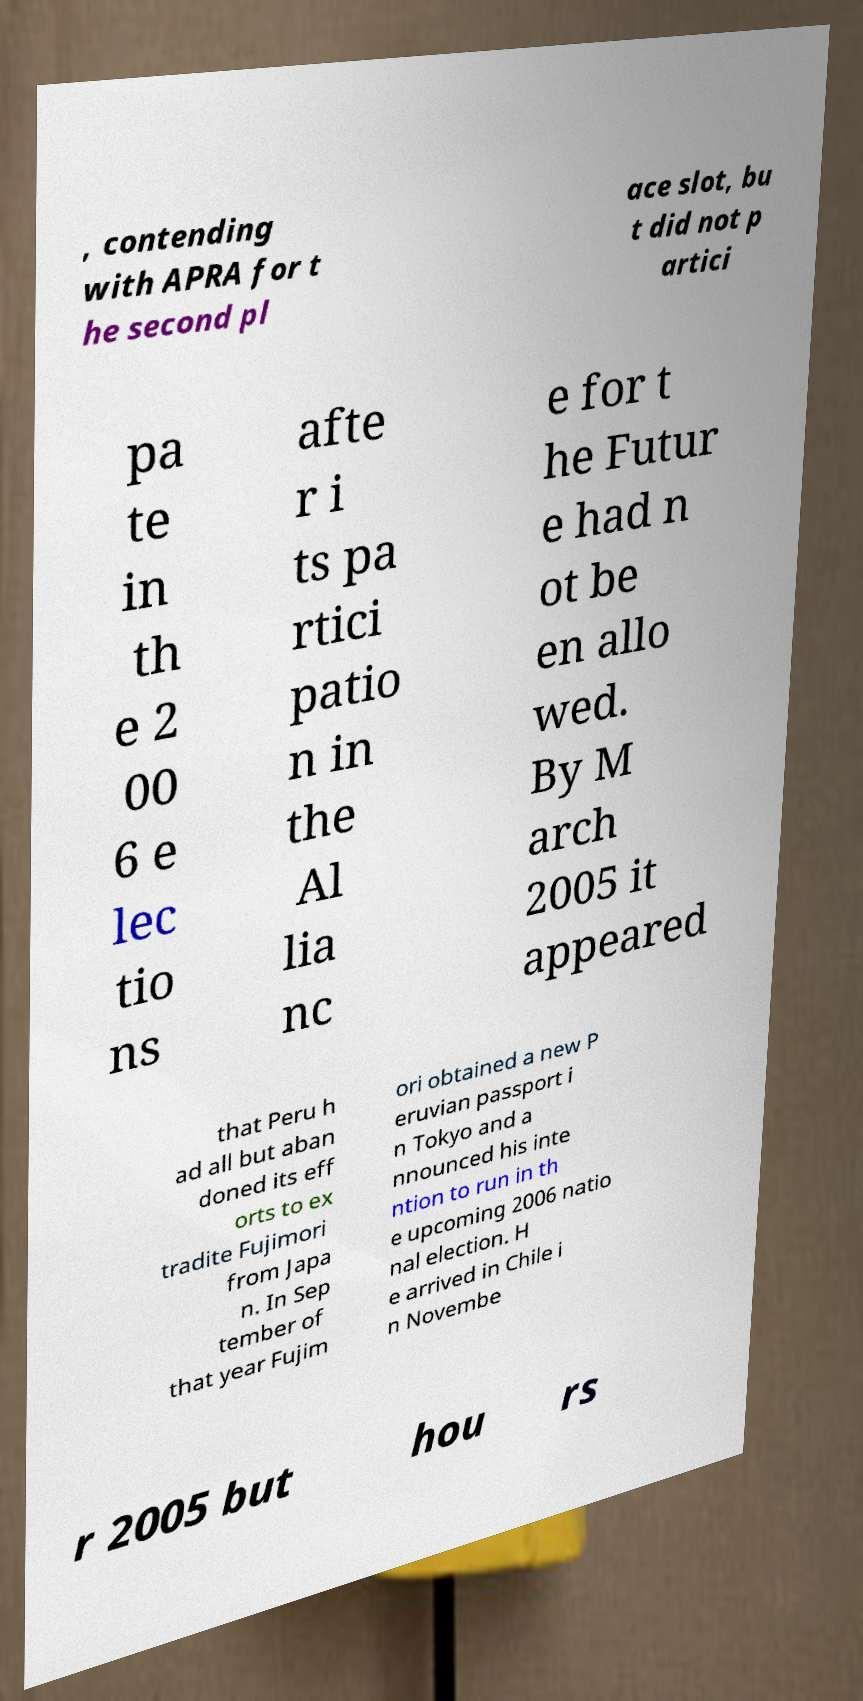There's text embedded in this image that I need extracted. Can you transcribe it verbatim? , contending with APRA for t he second pl ace slot, bu t did not p artici pa te in th e 2 00 6 e lec tio ns afte r i ts pa rtici patio n in the Al lia nc e for t he Futur e had n ot be en allo wed. By M arch 2005 it appeared that Peru h ad all but aban doned its eff orts to ex tradite Fujimori from Japa n. In Sep tember of that year Fujim ori obtained a new P eruvian passport i n Tokyo and a nnounced his inte ntion to run in th e upcoming 2006 natio nal election. H e arrived in Chile i n Novembe r 2005 but hou rs 